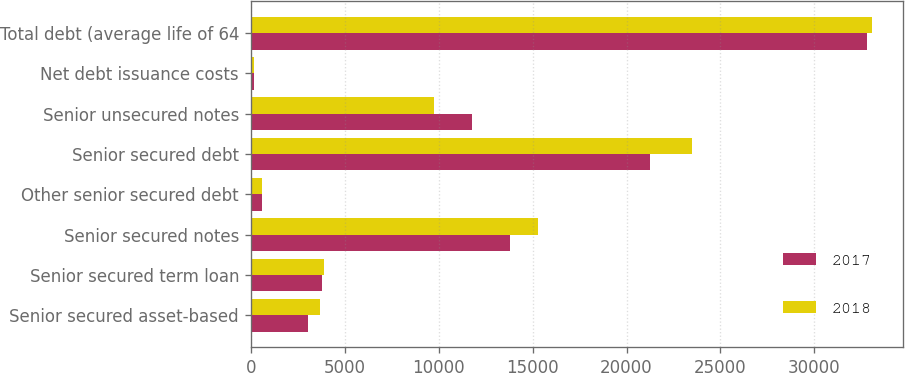<chart> <loc_0><loc_0><loc_500><loc_500><stacked_bar_chart><ecel><fcel>Senior secured asset-based<fcel>Senior secured term loan<fcel>Senior secured notes<fcel>Other senior secured debt<fcel>Senior secured debt<fcel>Senior unsecured notes<fcel>Net debt issuance costs<fcel>Total debt (average life of 64<nl><fcel>2017<fcel>3040<fcel>3801<fcel>13800<fcel>585<fcel>21226<fcel>11752<fcel>157<fcel>32821<nl><fcel>2018<fcel>3680<fcel>3891<fcel>15300<fcel>599<fcel>23470<fcel>9752<fcel>164<fcel>33058<nl></chart> 